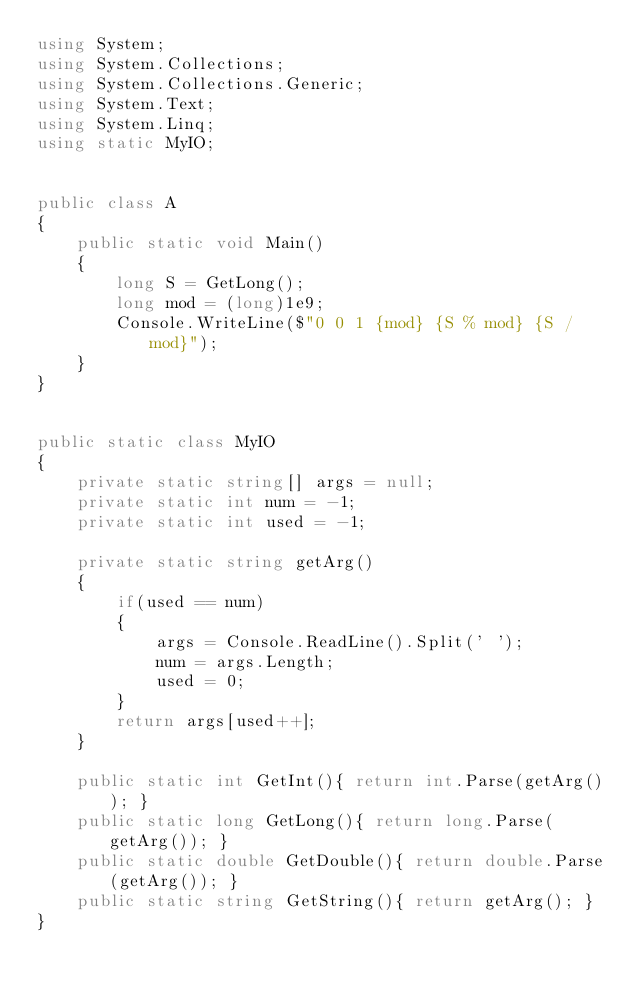<code> <loc_0><loc_0><loc_500><loc_500><_C#_>using System;
using System.Collections;
using System.Collections.Generic;
using System.Text;
using System.Linq;
using static MyIO;


public class A
{
	public static void Main()
	{
		long S = GetLong();
		long mod = (long)1e9;
		Console.WriteLine($"0 0 1 {mod} {S % mod} {S / mod}");
	}
}


public static class MyIO
{
	private static string[] args = null;
	private static int num = -1;
	private static int used = -1;

	private static string getArg()
	{
		if(used == num)
		{
			args = Console.ReadLine().Split(' ');
			num = args.Length;
			used = 0;
		}
		return args[used++];
	}

	public static int GetInt(){ return int.Parse(getArg()); }
	public static long GetLong(){ return long.Parse(getArg()); }
	public static double GetDouble(){ return double.Parse(getArg()); }
	public static string GetString(){ return getArg(); }
}</code> 